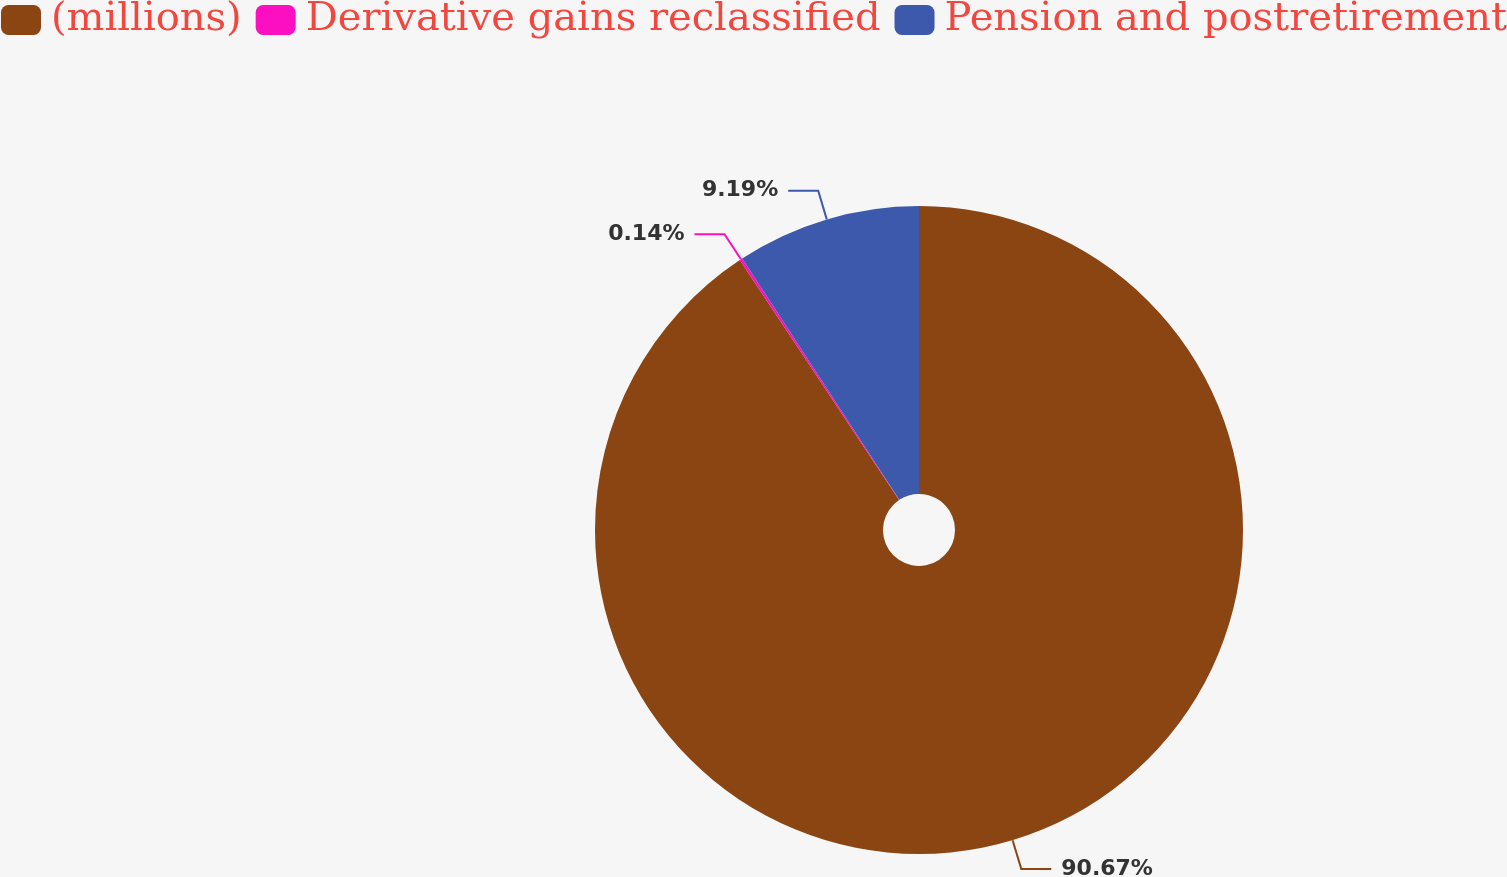Convert chart. <chart><loc_0><loc_0><loc_500><loc_500><pie_chart><fcel>(millions)<fcel>Derivative gains reclassified<fcel>Pension and postretirement<nl><fcel>90.68%<fcel>0.14%<fcel>9.19%<nl></chart> 